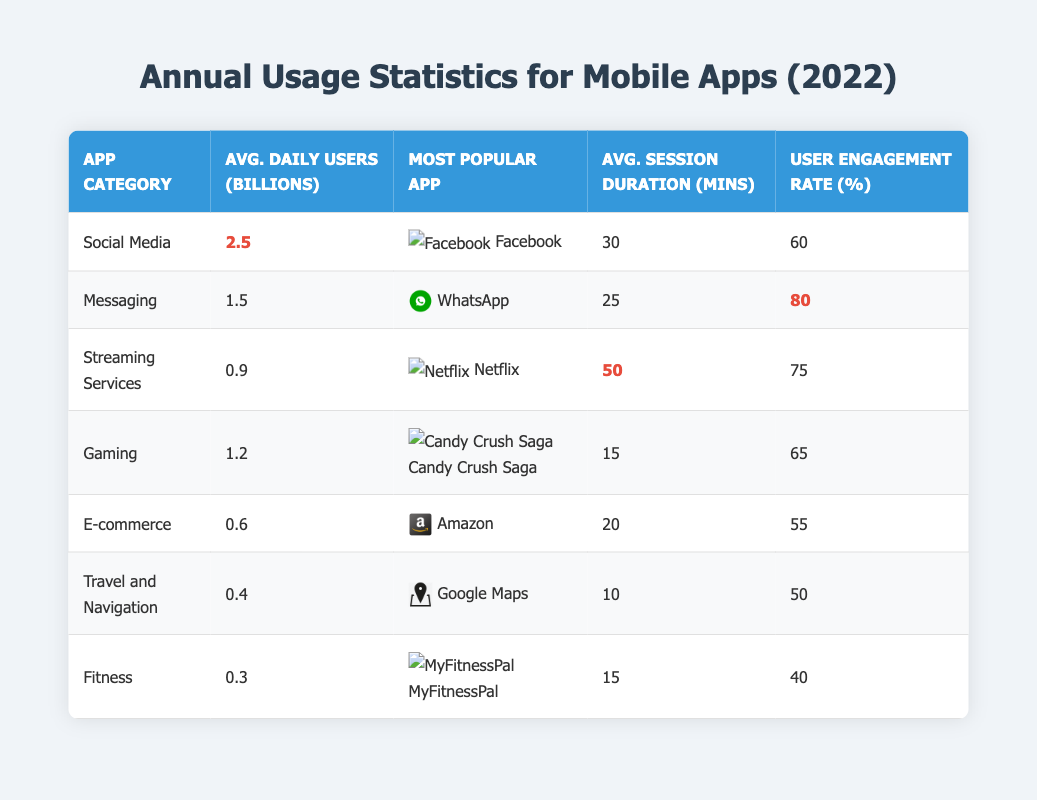What is the most popular app in the E-commerce category? Referring to the table, the most popular app listed under the E-commerce category is Amazon.
Answer: Amazon How many average daily users does the Social Media category have? The average daily users for the Social Media category, as shown in the table, is 2.5 billion.
Answer: 2.5 billion Which app category has the highest user engagement rate? By examining the user engagement rates in the table, Messaging has the highest rate at 80%.
Answer: Messaging What is the average session duration for Streaming Services? According to the table, the average session duration for Streaming Services is 50 minutes.
Answer: 50 minutes How does the average daily user count of Gaming compare to Fitness? The average daily users for Gaming is 1.2 billion, while for Fitness it is 0.3 billion. The difference in average daily users is 1.2 - 0.3 = 0.9 billion, meaning Gaming has 0.9 billion more users.
Answer: 0.9 billion more users Is the user engagement rate for Google Maps higher than that of Amazon? The user engagement rate for Google Maps is 50%, while for Amazon, it is 55%. Since 50% is not higher than 55%, the answer is no.
Answer: No What is the total average daily users for Social Media and Messaging combined? The average daily users for Social Media is 2.5 billion, and for Messaging, it is 1.5 billion. Adding these two values gives 2.5 + 1.5 = 4.0 billion.
Answer: 4.0 billion If we consider the session duration for both Gaming and Fitness, what is their average duration? The session duration for Gaming is 15 minutes, and for Fitness, it is also 15 minutes. Their average is (15 + 15) / 2 = 15 minutes.
Answer: 15 minutes Is the user engagement rate for Streaming Services above 70%? The user engagement rate for Streaming Services is 75%, which is indeed above 70%.
Answer: Yes What is the difference in average session duration between the Social Media and E-commerce categories? The average session duration for Social Media is 30 minutes and for E-commerce is 20 minutes. The difference is 30 - 20 = 10 minutes.
Answer: 10 minutes 